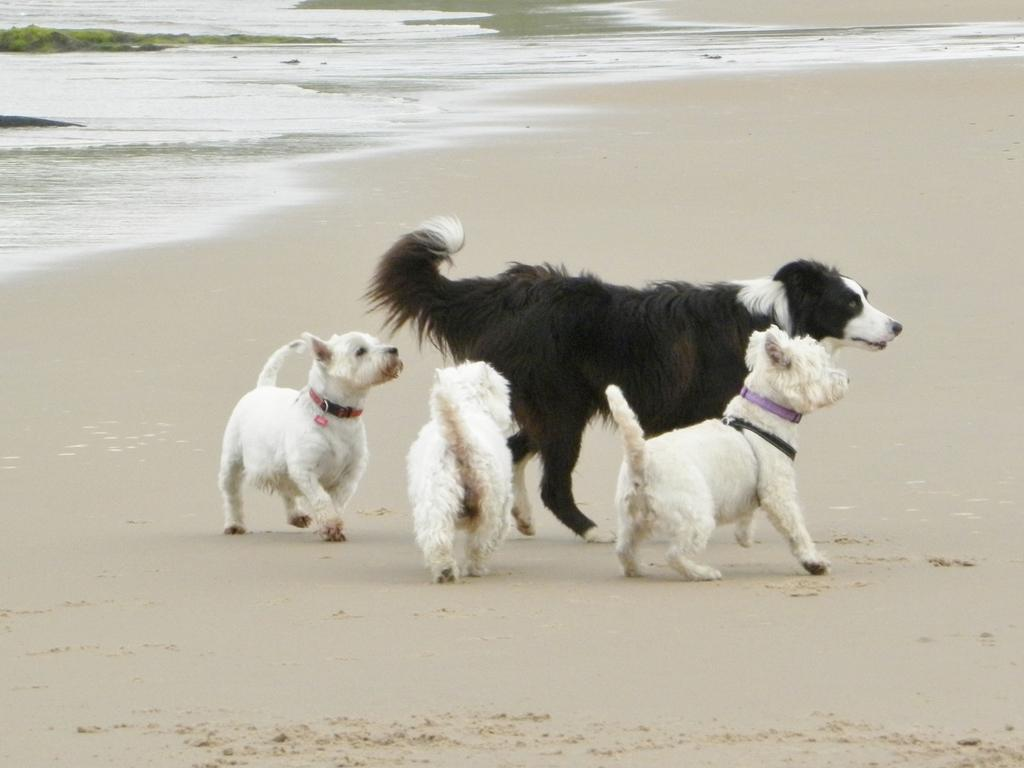What can be seen towards the top of the image? There is water towards the top of the image. What type of vegetation is visible towards the left of the image? There is grass towards the left of the image. What type of terrain is present in the image? There is sand in the image. What type of animal is in the image? There is a dog in the image. How many puppies are in the image? There are three puppies in the image. What type of canvas is being used by the children in the image? There are no children or canvas present in the image. What type of vacation is being depicted in the image? The image does not depict a vacation; it simply shows a dog and three puppies in a sandy area with grass and water. 